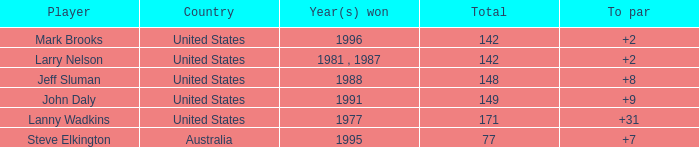State the overall amount of jeff sluman's successes. 148.0. 